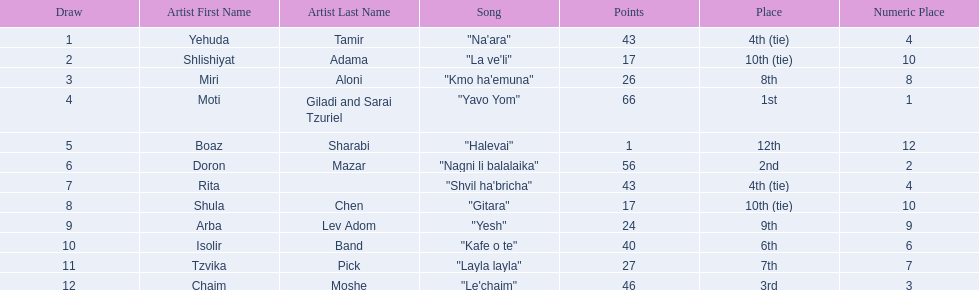What song earned the most points? "Yavo Yom". 